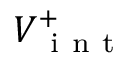<formula> <loc_0><loc_0><loc_500><loc_500>V _ { i n t } ^ { + }</formula> 